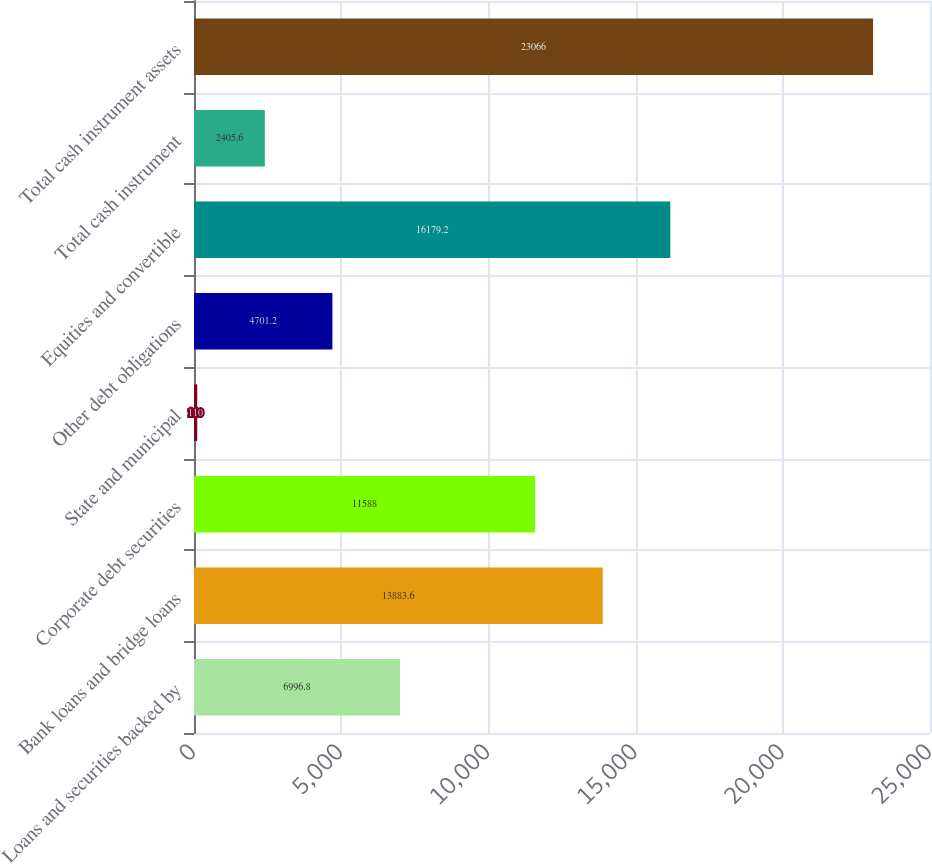Convert chart. <chart><loc_0><loc_0><loc_500><loc_500><bar_chart><fcel>Loans and securities backed by<fcel>Bank loans and bridge loans<fcel>Corporate debt securities<fcel>State and municipal<fcel>Other debt obligations<fcel>Equities and convertible<fcel>Total cash instrument<fcel>Total cash instrument assets<nl><fcel>6996.8<fcel>13883.6<fcel>11588<fcel>110<fcel>4701.2<fcel>16179.2<fcel>2405.6<fcel>23066<nl></chart> 